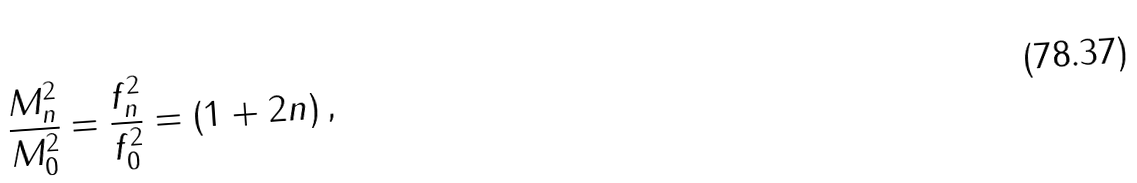<formula> <loc_0><loc_0><loc_500><loc_500>\frac { M _ { n } ^ { 2 } } { M _ { 0 } ^ { 2 } } = \frac { f _ { n } ^ { 2 } } { f _ { 0 } ^ { 2 } } = ( 1 + 2 n ) \, ,</formula> 